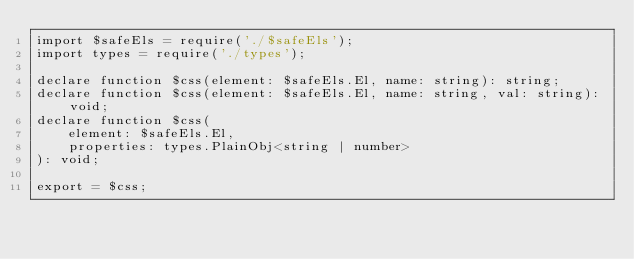<code> <loc_0><loc_0><loc_500><loc_500><_TypeScript_>import $safeEls = require('./$safeEls');
import types = require('./types');

declare function $css(element: $safeEls.El, name: string): string;
declare function $css(element: $safeEls.El, name: string, val: string): void;
declare function $css(
    element: $safeEls.El,
    properties: types.PlainObj<string | number>
): void;

export = $css;
</code> 